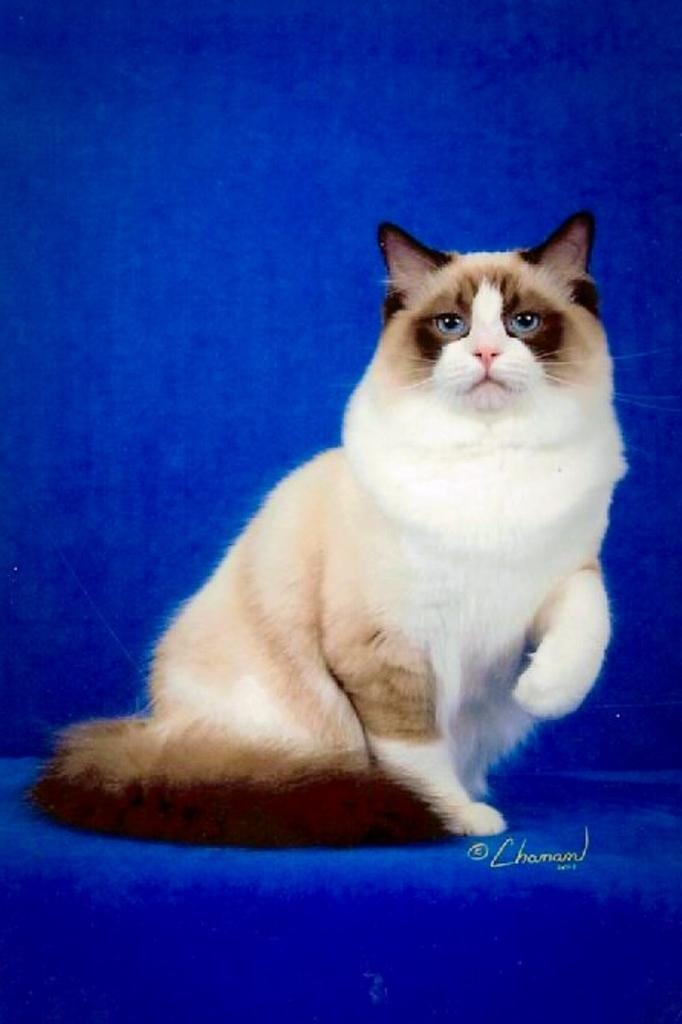What is the main subject in the center of the image? There is a cat in the center of the image. What colors are present at the top and bottom of the image? The top and bottom of the image are blue. How does the cat help with the spoon in the image? There is no spoon present in the image, and the cat is not shown helping with any object. 